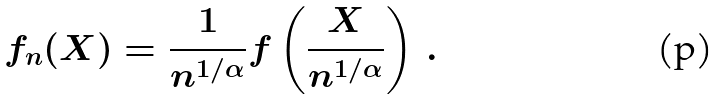<formula> <loc_0><loc_0><loc_500><loc_500>f _ { n } ( X ) = \frac { 1 } { n ^ { 1 / \alpha } } f \left ( \frac { X } { n ^ { 1 / \alpha } } \right ) \, .</formula> 